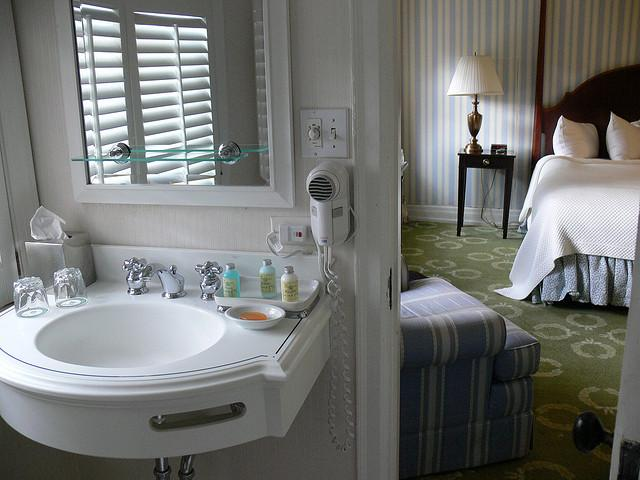What is the corded device called that's on the wall? hair dryer 